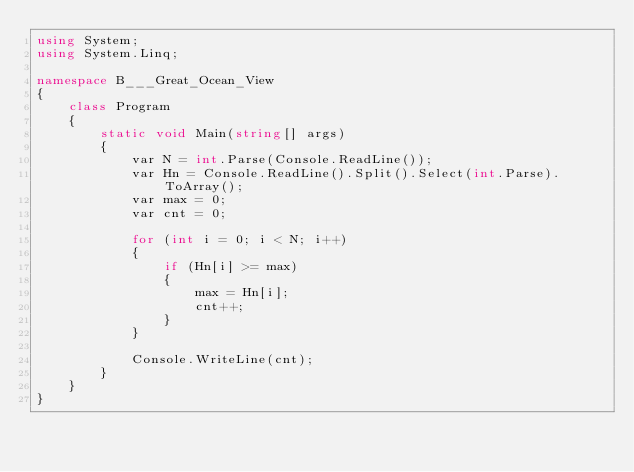Convert code to text. <code><loc_0><loc_0><loc_500><loc_500><_C#_>using System;
using System.Linq;

namespace B___Great_Ocean_View
{
    class Program
    {
        static void Main(string[] args)
        {
            var N = int.Parse(Console.ReadLine());
            var Hn = Console.ReadLine().Split().Select(int.Parse).ToArray();
            var max = 0;
            var cnt = 0;

            for (int i = 0; i < N; i++)
            {
                if (Hn[i] >= max)
                {
                    max = Hn[i];
                    cnt++;
                }
            }

            Console.WriteLine(cnt);
        }
    }
}
</code> 